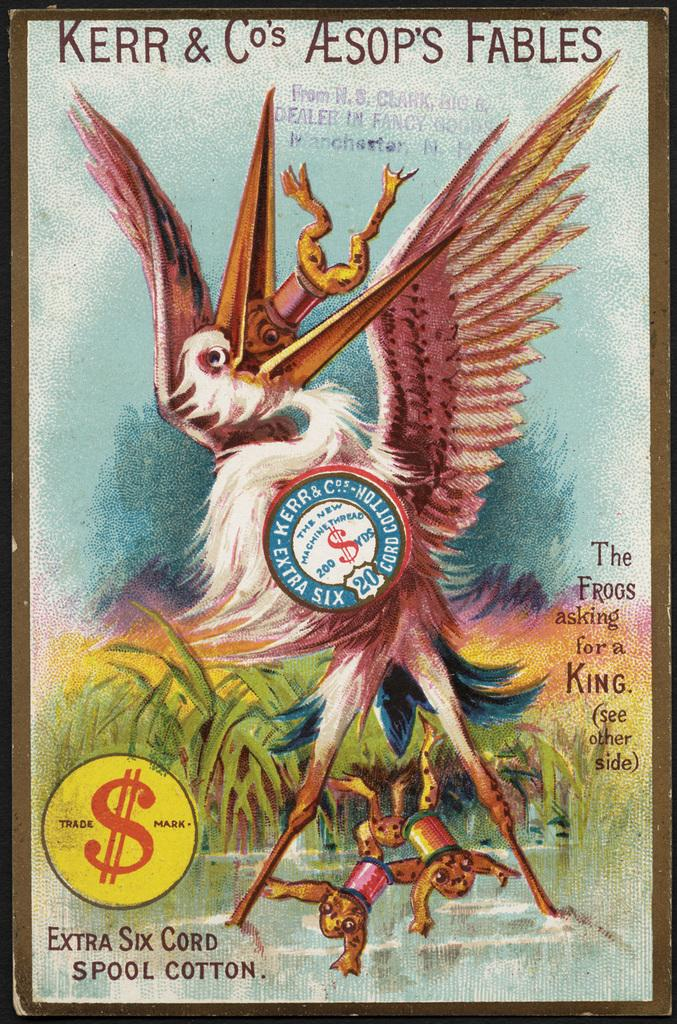<image>
Write a terse but informative summary of the picture. The cover of a book with a stork and frog drawing with the title Kerr & co's Aesop's Fables 